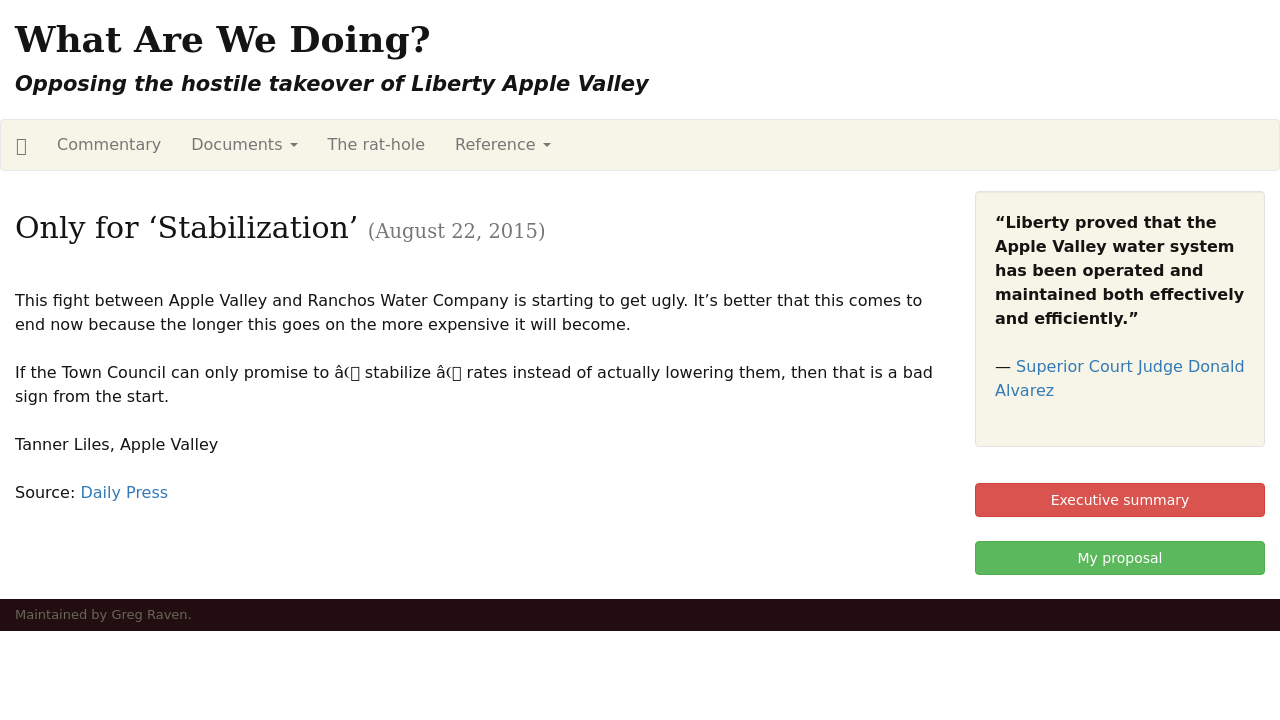What might be the purpose of the red buttons like 'Executive summary' and 'My proposal' showcased in the image? The red buttons labeled 'Executive summary' and 'My proposal' in the image likely serve as critical navigation elements designed to direct visitors quickly to essential information. The 'Executive summary' button could provide a concise overview of the site's main issues and arguments against the takeover, summarizing key points for quick reader understanding. On the other hand, the 'My proposal' button probably leads to a detailed plan or alternative solutions proposed by the site contributors concerning the water system takeover. These buttons are useful for improving user experience by providing immediate access to important sections, presenting the site's content effectively and facilitating easy navigation. 